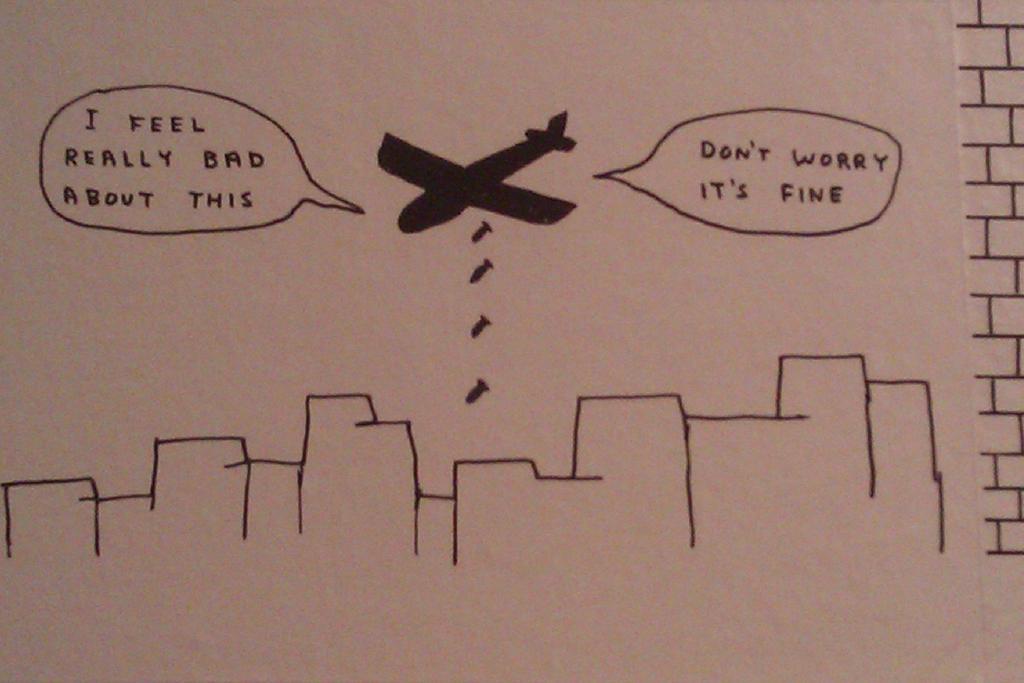In one or two sentences, can you explain what this image depicts? In this image there is some text written and there is a drawing of an airplane. 